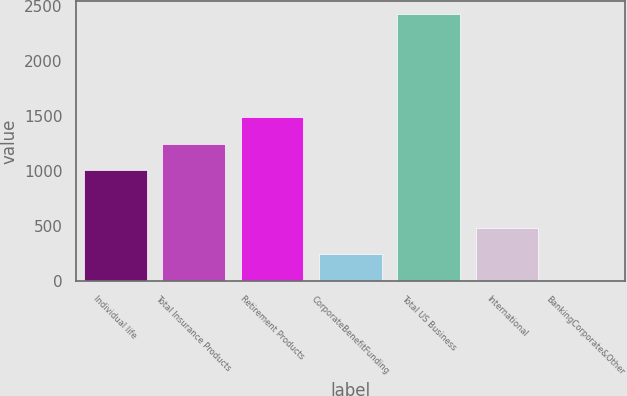Convert chart to OTSL. <chart><loc_0><loc_0><loc_500><loc_500><bar_chart><fcel>Individual life<fcel>Total Insurance Products<fcel>Retirement Products<fcel>CorporateBenefitFunding<fcel>Total US Business<fcel>International<fcel>BankingCorporate&Other<nl><fcel>1005<fcel>1246.8<fcel>1488.6<fcel>242.8<fcel>2419<fcel>484.6<fcel>1<nl></chart> 